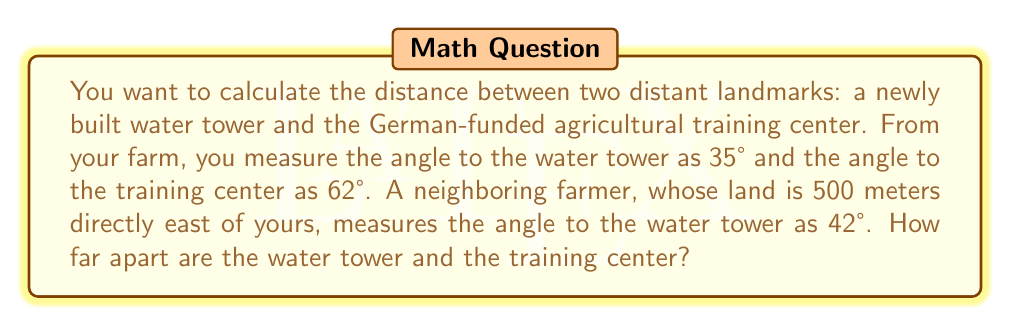Solve this math problem. Let's approach this step-by-step:

1) First, we need to find the distance to the water tower from your farm. We can use the law of sines for this.

2) Let's draw a triangle with your farm (A), your neighbor's farm (B), and the water tower (C).

[asy]
import geometry;

pair A = (0,0);
pair B = (5,0);
pair C = (2,4);

draw(A--B--C--A);

label("A (Your farm)", A, SW);
label("B (Neighbor's farm)", B, SE);
label("C (Water tower)", C, N);

label("500m", (A+B)/2, S);
label("35°", A, NE);
label("42°", B, NW);

[/asy]

3) We know:
   - The distance AB is 500 meters
   - Angle CAB is 35°
   - Angle CBA is 42°

4) Using the law of sines:

   $$\frac{AC}{\sin(42°)} = \frac{500}{\sin(180°-(35°+42°))} = \frac{500}{\sin(103°)}$$

5) Solving for AC:

   $$AC = \frac{500 \sin(42°)}{\sin(103°)} \approx 345.3 \text{ meters}$$

6) Now we know the distance to the water tower. We can use this to find the distance to the training center.

7) Let's draw another triangle with your farm (A), the water tower (C), and the training center (D).

[asy]
import geometry;

pair A = (0,0);
pair C = (3,4);
pair D = (5,2);

draw(A--C--D--A);

label("A (Your farm)", A, SW);
label("C (Water tower)", C, N);
label("D (Training center)", D, E);

label("345.3m", (A+C)/2, NW);
label("35°", A, NE);
label("62°", A, SE);

[/asy]

8) We know:
   - AC is 345.3 meters
   - Angle CAD is 62° - 35° = 27°

9) We can use the law of sines again:

   $$\frac{CD}{\sin(27°)} = \frac{345.3}{\sin(180°-(27°+35°))} = \frac{345.3}{\sin(118°)}$$

10) Solving for CD:

    $$CD = \frac{345.3 \sin(27°)}{\sin(118°)} \approx 163.7 \text{ meters}$$

Therefore, the distance between the water tower and the training center is approximately 163.7 meters.
Answer: $163.7 \text{ meters}$ 